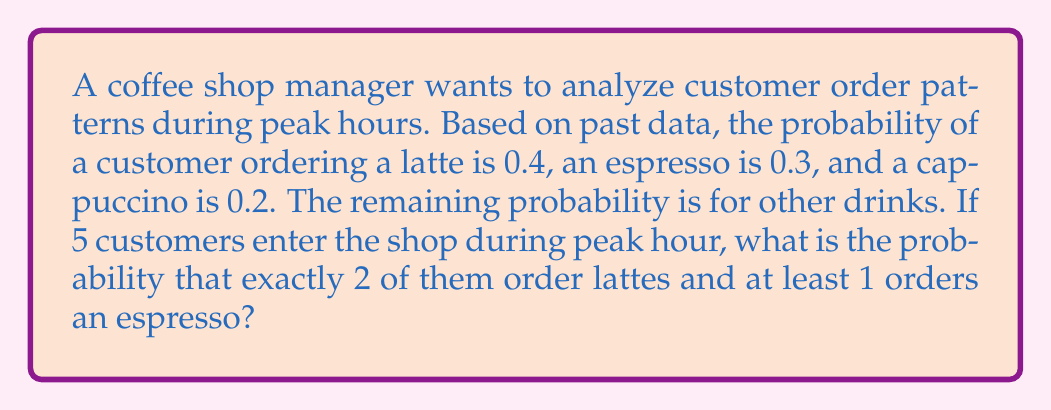Show me your answer to this math problem. Let's approach this step-by-step:

1) First, we need to use the binomial probability formula for exactly 2 lattes out of 5 customers:

   $P(\text{2 lattes}) = \binom{5}{2} (0.4)^2 (0.6)^3$

   Where $\binom{5}{2} = \frac{5!}{2!(5-2)!} = 10$

   So, $P(\text{2 lattes}) = 10 \cdot 0.16 \cdot 0.216 = 0.3456$

2) Now, for the espresso part, we need to calculate the probability of at least 1 espresso in the remaining 3 customers. It's easier to calculate the probability of no espressos and subtract from 1:

   $P(\text{at least 1 espresso in 3}) = 1 - P(\text{no espresso in 3})$
   $= 1 - (0.7)^3 = 1 - 0.343 = 0.657$

3) The probability of both events occurring is the product of their individual probabilities:

   $P(\text{2 lattes AND at least 1 espresso}) = 0.3456 \cdot 0.657 = 0.2271$

Therefore, the probability is approximately 0.2271 or 22.71%.
Answer: 0.2271 